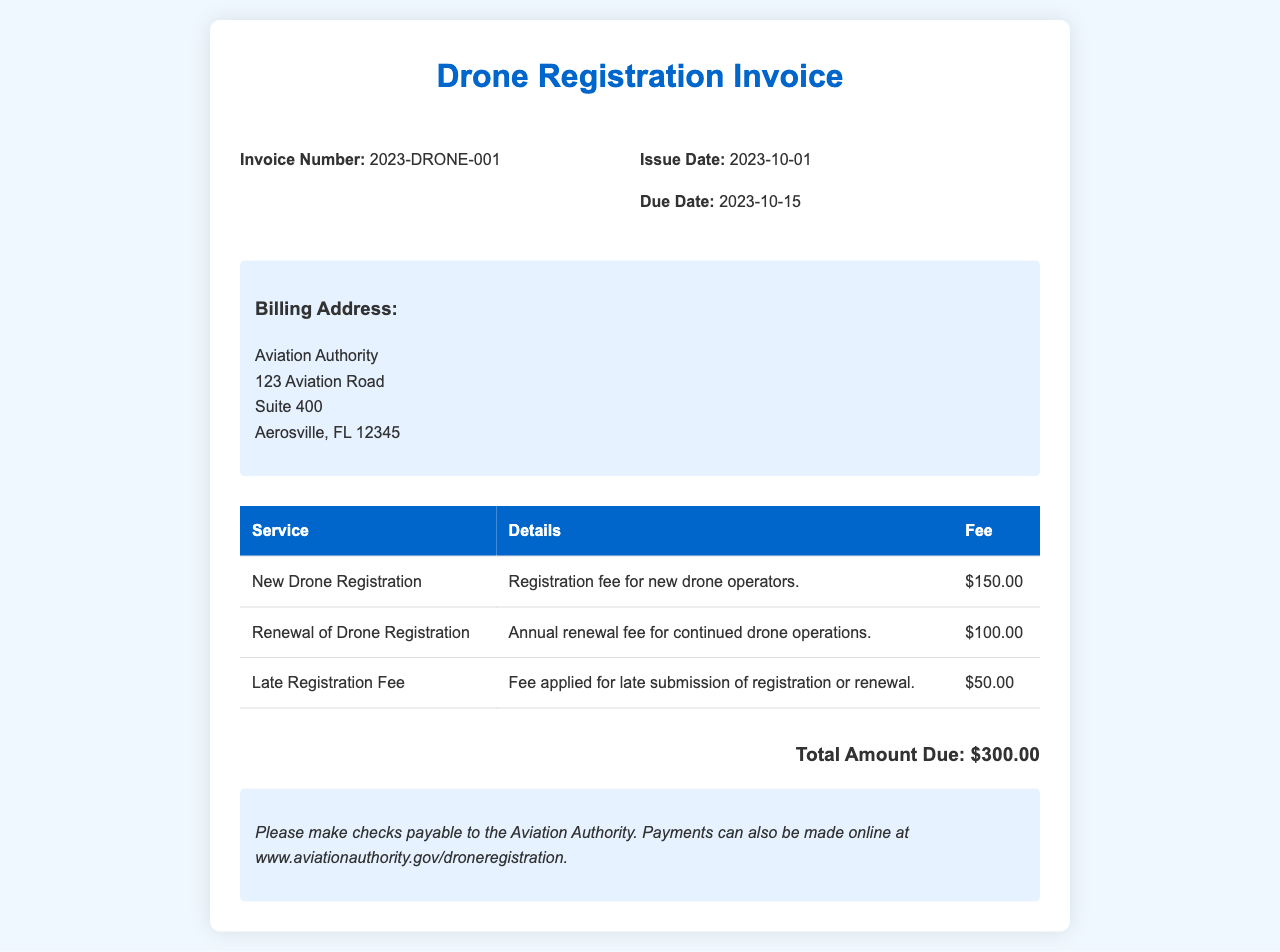What is the invoice number? The invoice number is specifically stated in the document, which is 2023-DRONE-001.
Answer: 2023-DRONE-001 What is the issue date of the invoice? The issue date is mentioned in the invoice details section, which is 2023-10-01.
Answer: 2023-10-01 What is the amount due for late registration? The fee for late submission of registration or renewal is specified in the table, which is $50.00.
Answer: $50.00 How much is the fee for new drone registration? The fee for new drone registration is clearly indicated in the document, which is $150.00.
Answer: $150.00 What is the total amount due? The total amount due is summarized at the end of the document, which totals $300.00.
Answer: $300.00 What is the due date for this invoice? The due date is provided in the invoice details section, which is 2023-10-15.
Answer: 2023-10-15 What payment methods are mentioned? The document mentions checks and online payments as payment methods.
Answer: Checks and online payments Why is there a late registration fee? The late registration fee is applied specifically for the late submission of registration or renewal.
Answer: For late submission What is the renewal fee for drone registration? The document lists the annual renewal fee for continued operations as $100.00.
Answer: $100.00 